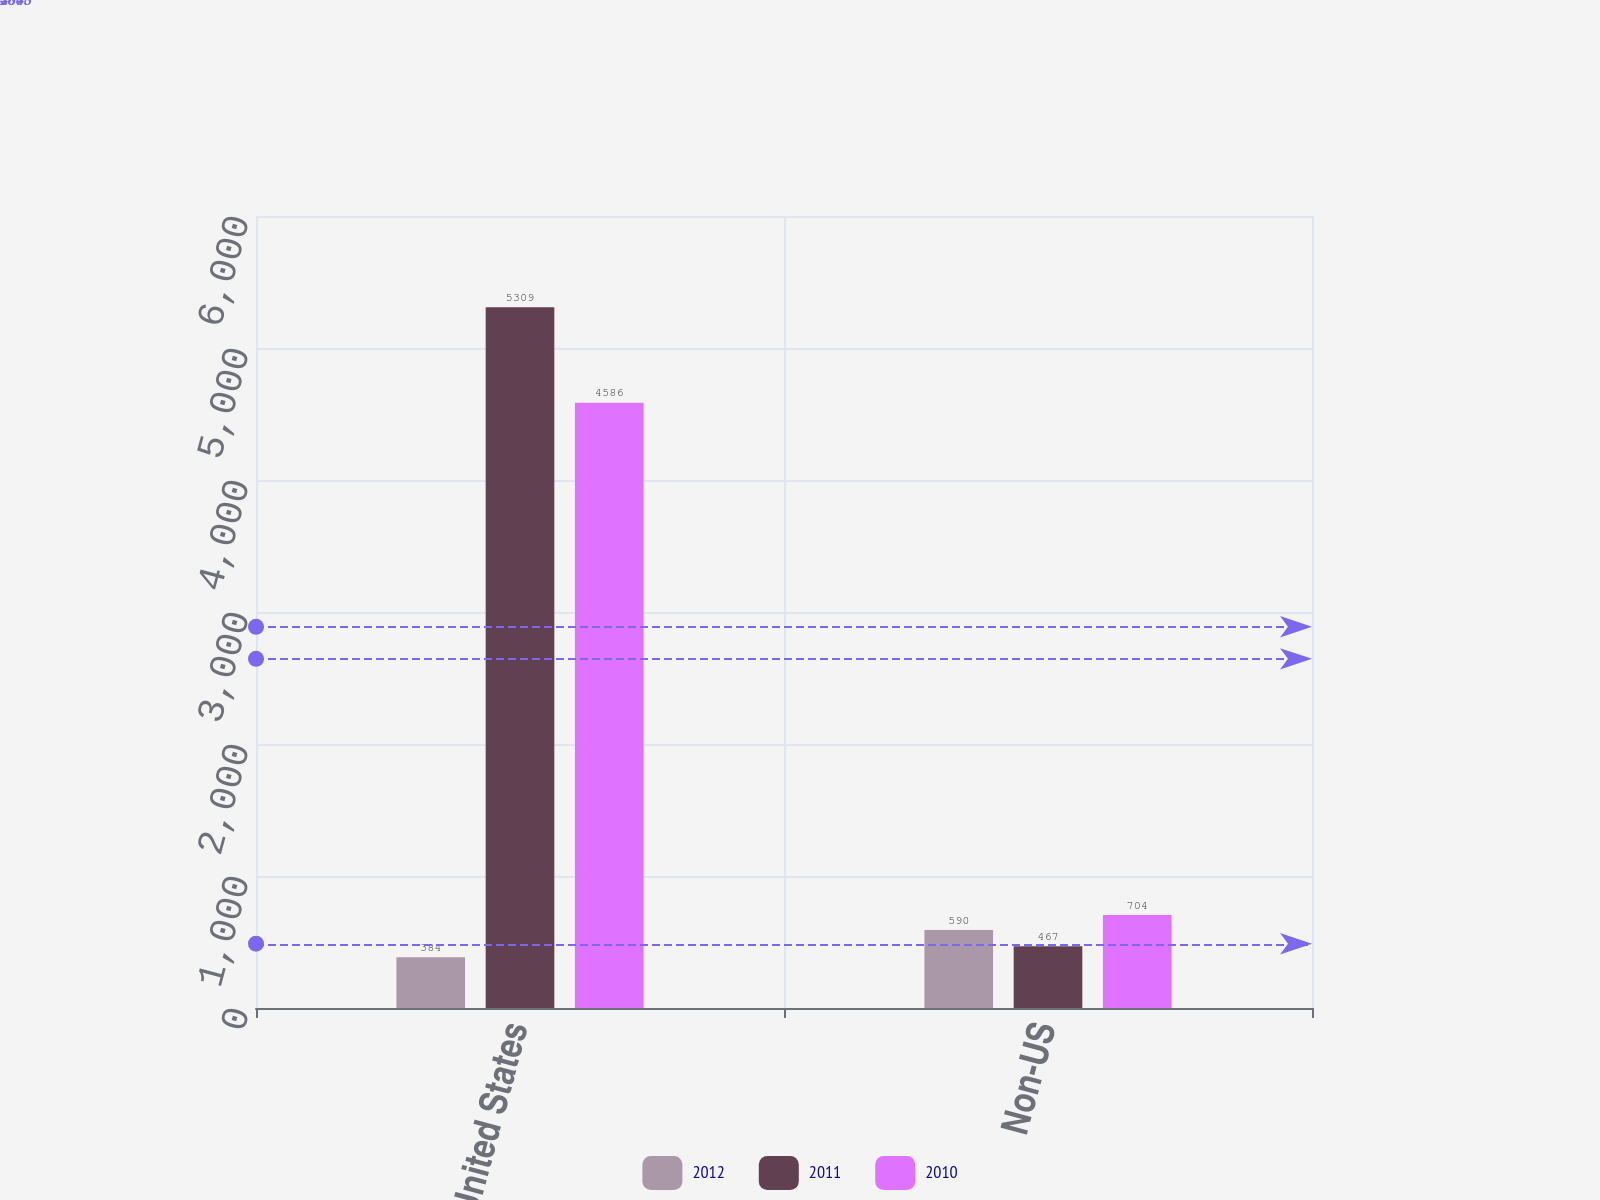Convert chart. <chart><loc_0><loc_0><loc_500><loc_500><stacked_bar_chart><ecel><fcel>United States<fcel>Non-US<nl><fcel>2012<fcel>384<fcel>590<nl><fcel>2011<fcel>5309<fcel>467<nl><fcel>2010<fcel>4586<fcel>704<nl></chart> 